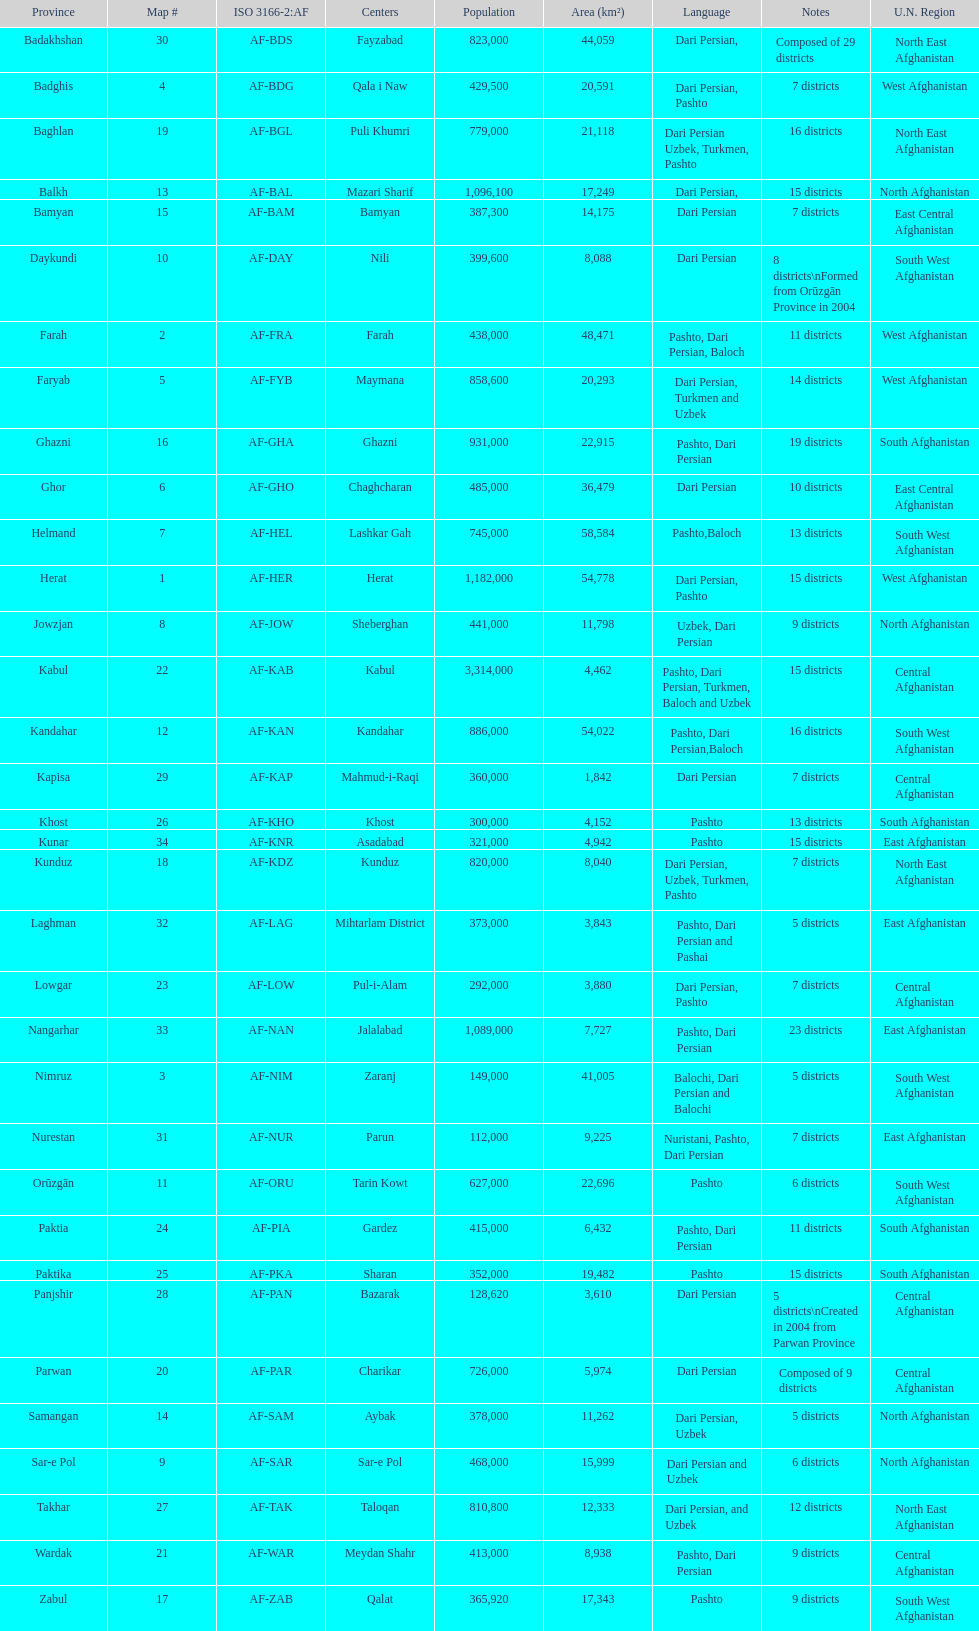What is the most populous province in afghanistan? Kabul. 